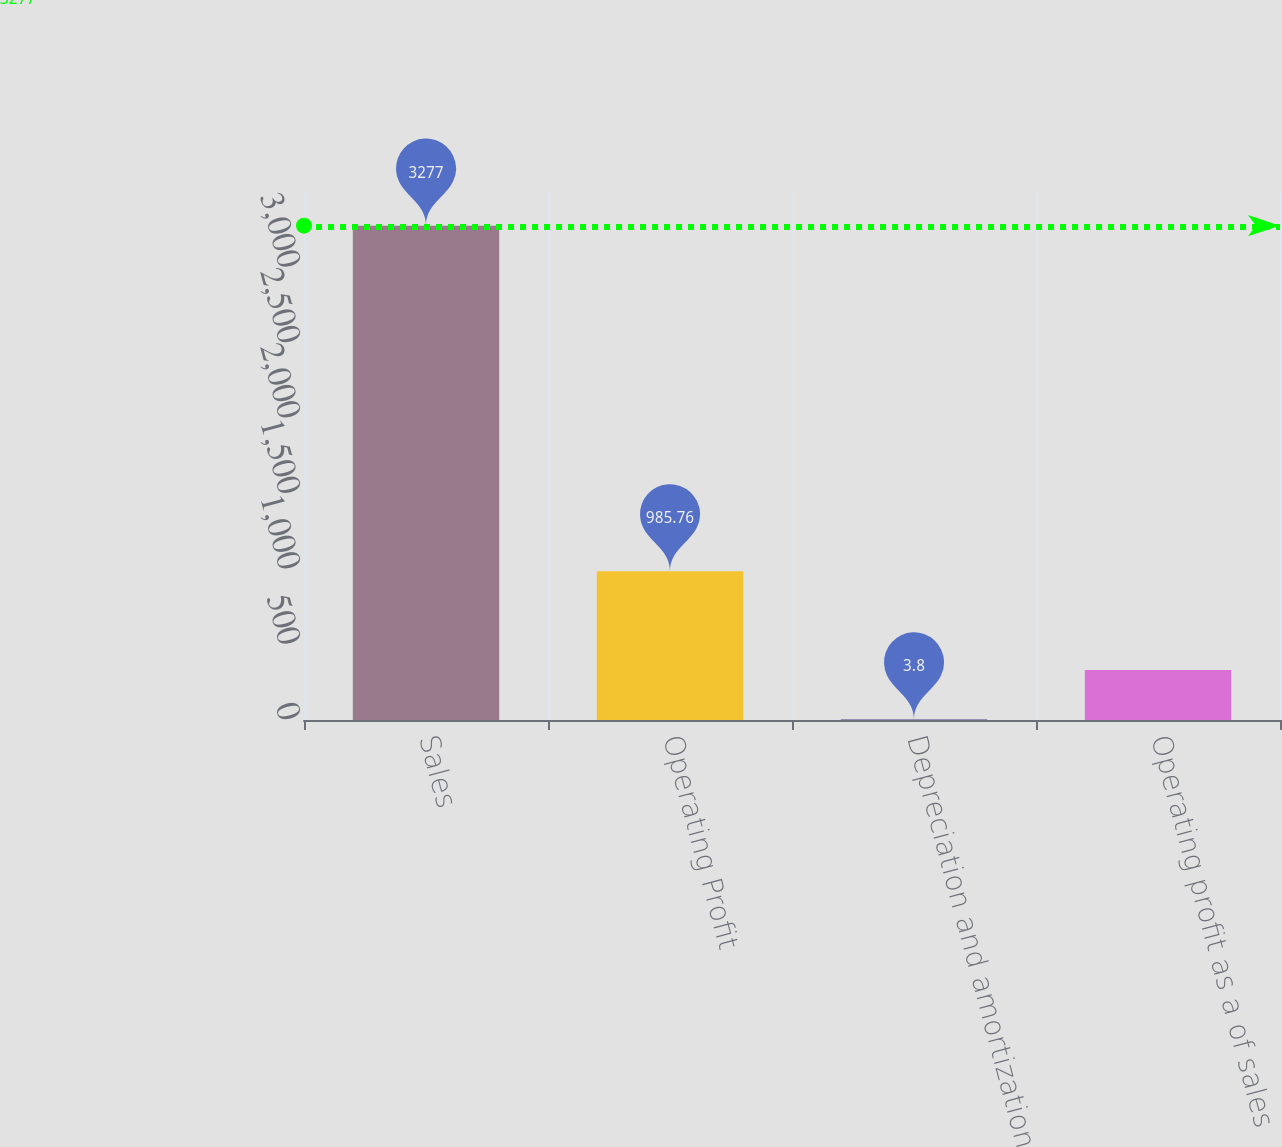Convert chart to OTSL. <chart><loc_0><loc_0><loc_500><loc_500><bar_chart><fcel>Sales<fcel>Operating Profit<fcel>Depreciation and amortization<fcel>Operating profit as a of sales<nl><fcel>3277<fcel>985.76<fcel>3.8<fcel>331.12<nl></chart> 